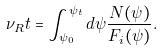<formula> <loc_0><loc_0><loc_500><loc_500>\nu _ { R } t = \int _ { \psi _ { 0 } } ^ { \psi _ { t } } d \psi \frac { N ( \psi ) } { F _ { i } ( \psi ) } .</formula> 